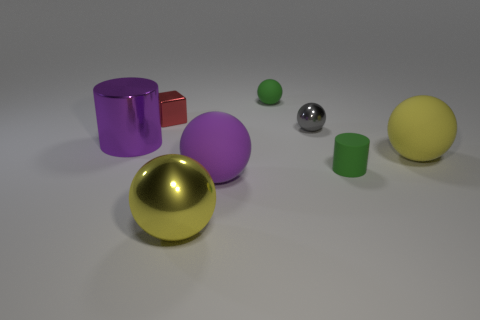Is the size of the red block the same as the gray sphere?
Make the answer very short. Yes. Are there any other things that have the same size as the green ball?
Your answer should be compact. Yes. What color is the small thing that is the same material as the red block?
Make the answer very short. Gray. Are there fewer tiny matte objects to the left of the tiny cylinder than big yellow shiny balls that are to the left of the large metallic cylinder?
Provide a short and direct response. No. How many big balls are the same color as the tiny rubber cylinder?
Give a very brief answer. 0. There is a large sphere that is the same color as the metal cylinder; what is it made of?
Ensure brevity in your answer.  Rubber. How many objects are both on the left side of the yellow shiny thing and in front of the gray ball?
Your answer should be compact. 1. The yellow sphere that is behind the metal sphere in front of the small gray sphere is made of what material?
Your answer should be compact. Rubber. Is there a tiny purple cylinder made of the same material as the gray ball?
Ensure brevity in your answer.  No. There is a block that is the same size as the matte cylinder; what material is it?
Offer a very short reply. Metal. 